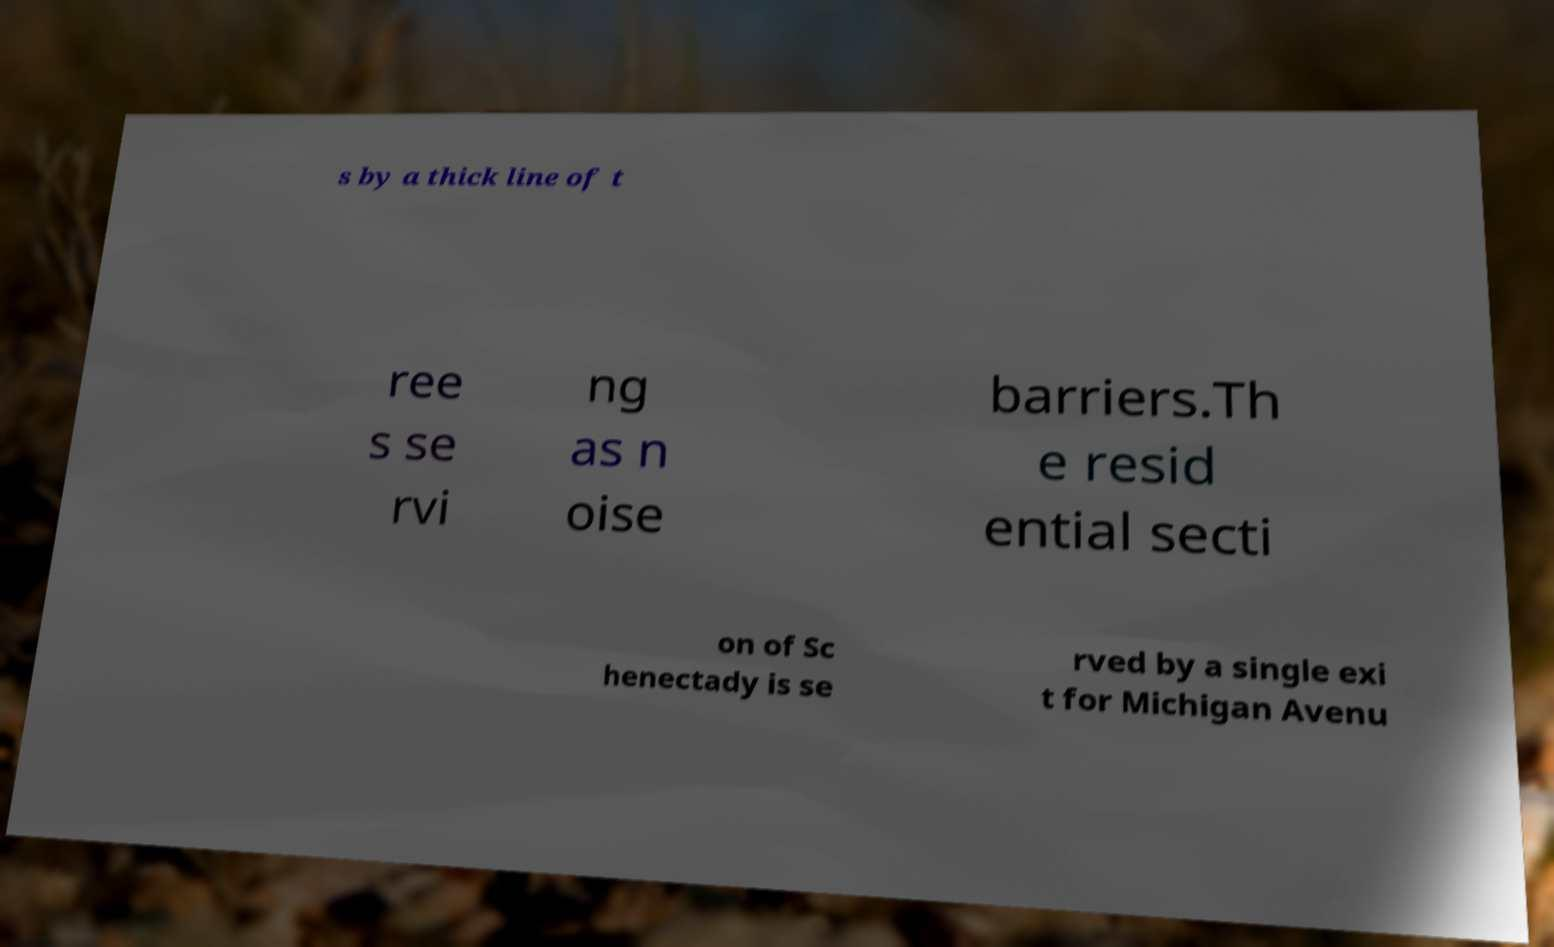There's text embedded in this image that I need extracted. Can you transcribe it verbatim? s by a thick line of t ree s se rvi ng as n oise barriers.Th e resid ential secti on of Sc henectady is se rved by a single exi t for Michigan Avenu 